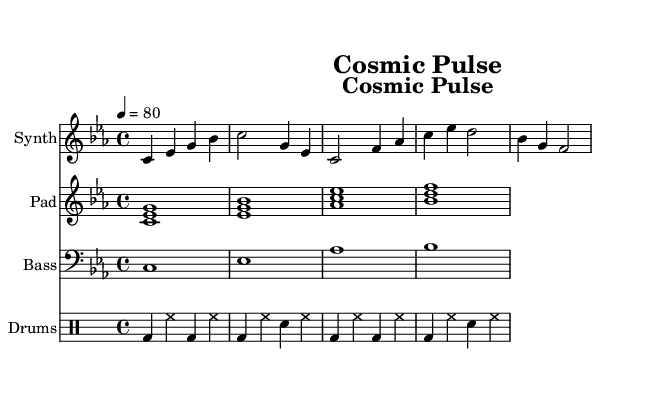What is the key signature of this music? The key signature is indicated by the accidental symbols at the beginning of the staff. In this case, it shows three flats (B flat, E flat, and A flat), which indicates the key of C minor.
Answer: C minor What is the time signature of the piece? The time signature is located at the beginning of the score and is written as a fraction. Here, it is shown as "4/4", which means there are four beats in each measure.
Answer: 4/4 What is the tempo marking of the piece? The tempo marking is found at the beginning of the score as well, noted as "4 = 80". This indicates that there should be 80 beats per minute.
Answer: 80 How many different instrument staves are present in the score? By examining the score layout, we see that there are four distinct staves: Synth, Pad, Bass, and Drums. Counting these gives us the total number of instrument types utilized.
Answer: Four What type of drum pattern is used? The drum pattern is indicated in the drum staff; it shows a repeating sequence of bass drums and hi-hats, followed by snare drums. This pattern reflects a common consistent rhythm typically seen in electronic music.
Answer: Repeating Which instrument plays the harmonic accompaniment? The harmonic accompaniment can be identified by observing that the "Pad" staff contains sustained chords that fill out the harmonic texture, typical for creating an ambient atmosphere in electronic music.
Answer: Pad What is the rhythmic structure of the synthesizer part? Looking closely at the synthesizer staff, we see a mix of quarter notes and half notes, creating a rhythm that enhances the melodic line. The specific combination can provide a driving feel to the electronic sound.
Answer: Quarter and half notes 